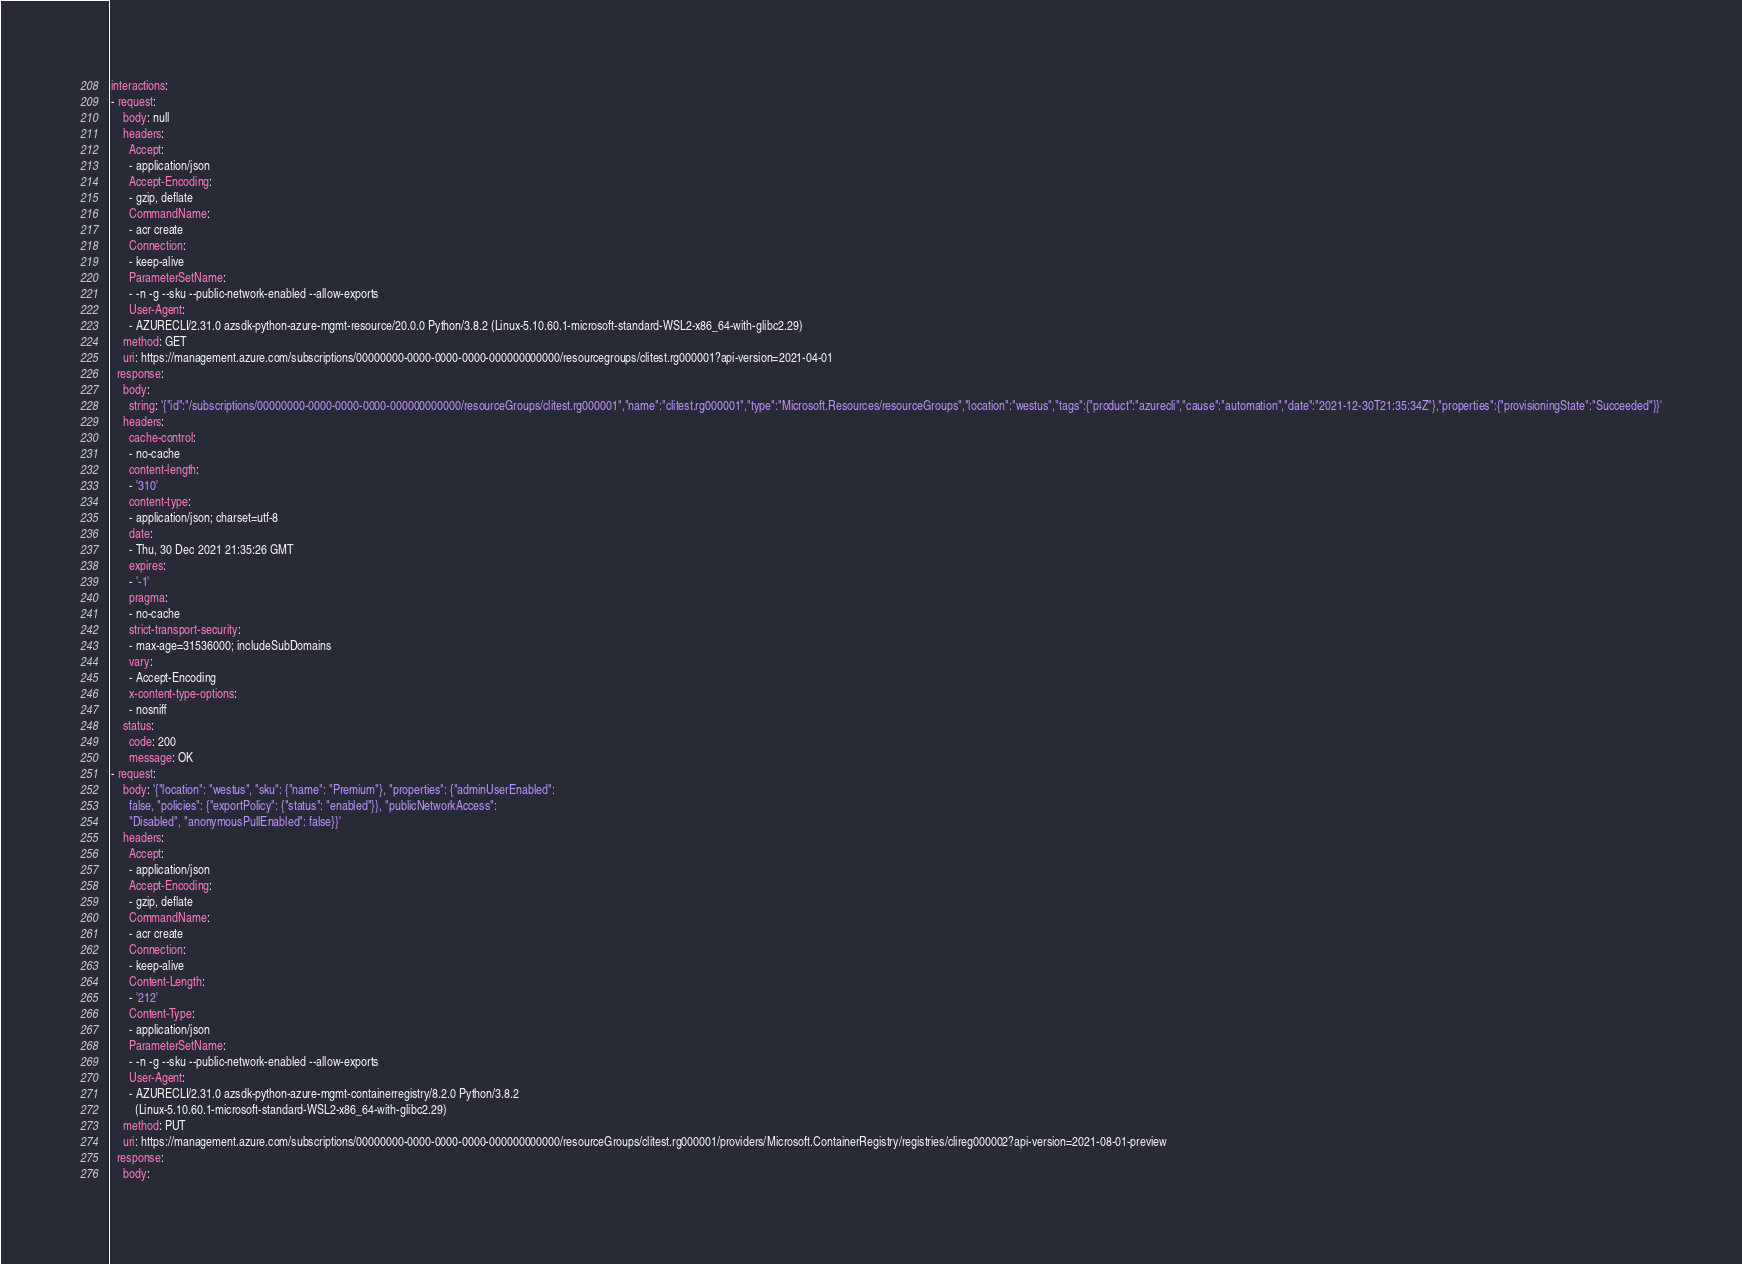Convert code to text. <code><loc_0><loc_0><loc_500><loc_500><_YAML_>interactions:
- request:
    body: null
    headers:
      Accept:
      - application/json
      Accept-Encoding:
      - gzip, deflate
      CommandName:
      - acr create
      Connection:
      - keep-alive
      ParameterSetName:
      - -n -g --sku --public-network-enabled --allow-exports
      User-Agent:
      - AZURECLI/2.31.0 azsdk-python-azure-mgmt-resource/20.0.0 Python/3.8.2 (Linux-5.10.60.1-microsoft-standard-WSL2-x86_64-with-glibc2.29)
    method: GET
    uri: https://management.azure.com/subscriptions/00000000-0000-0000-0000-000000000000/resourcegroups/clitest.rg000001?api-version=2021-04-01
  response:
    body:
      string: '{"id":"/subscriptions/00000000-0000-0000-0000-000000000000/resourceGroups/clitest.rg000001","name":"clitest.rg000001","type":"Microsoft.Resources/resourceGroups","location":"westus","tags":{"product":"azurecli","cause":"automation","date":"2021-12-30T21:35:34Z"},"properties":{"provisioningState":"Succeeded"}}'
    headers:
      cache-control:
      - no-cache
      content-length:
      - '310'
      content-type:
      - application/json; charset=utf-8
      date:
      - Thu, 30 Dec 2021 21:35:26 GMT
      expires:
      - '-1'
      pragma:
      - no-cache
      strict-transport-security:
      - max-age=31536000; includeSubDomains
      vary:
      - Accept-Encoding
      x-content-type-options:
      - nosniff
    status:
      code: 200
      message: OK
- request:
    body: '{"location": "westus", "sku": {"name": "Premium"}, "properties": {"adminUserEnabled":
      false, "policies": {"exportPolicy": {"status": "enabled"}}, "publicNetworkAccess":
      "Disabled", "anonymousPullEnabled": false}}'
    headers:
      Accept:
      - application/json
      Accept-Encoding:
      - gzip, deflate
      CommandName:
      - acr create
      Connection:
      - keep-alive
      Content-Length:
      - '212'
      Content-Type:
      - application/json
      ParameterSetName:
      - -n -g --sku --public-network-enabled --allow-exports
      User-Agent:
      - AZURECLI/2.31.0 azsdk-python-azure-mgmt-containerregistry/8.2.0 Python/3.8.2
        (Linux-5.10.60.1-microsoft-standard-WSL2-x86_64-with-glibc2.29)
    method: PUT
    uri: https://management.azure.com/subscriptions/00000000-0000-0000-0000-000000000000/resourceGroups/clitest.rg000001/providers/Microsoft.ContainerRegistry/registries/clireg000002?api-version=2021-08-01-preview
  response:
    body:</code> 